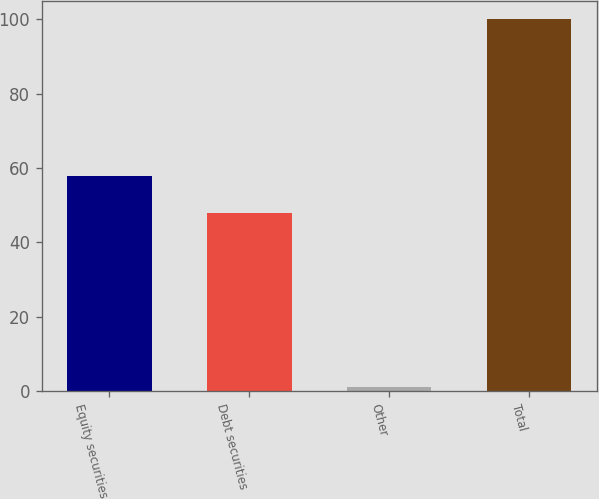Convert chart. <chart><loc_0><loc_0><loc_500><loc_500><bar_chart><fcel>Equity securities<fcel>Debt securities<fcel>Other<fcel>Total<nl><fcel>57.9<fcel>48<fcel>1<fcel>100<nl></chart> 